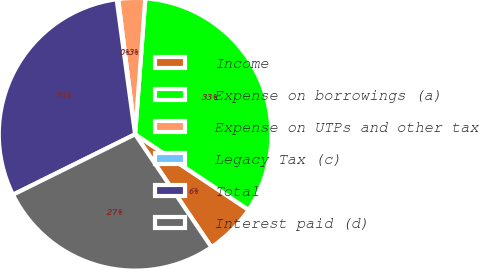<chart> <loc_0><loc_0><loc_500><loc_500><pie_chart><fcel>Income<fcel>Expense on borrowings (a)<fcel>Expense on UTPs and other tax<fcel>Legacy Tax (c)<fcel>Total<fcel>Interest paid (d)<nl><fcel>6.19%<fcel>33.16%<fcel>3.18%<fcel>0.18%<fcel>30.15%<fcel>27.15%<nl></chart> 